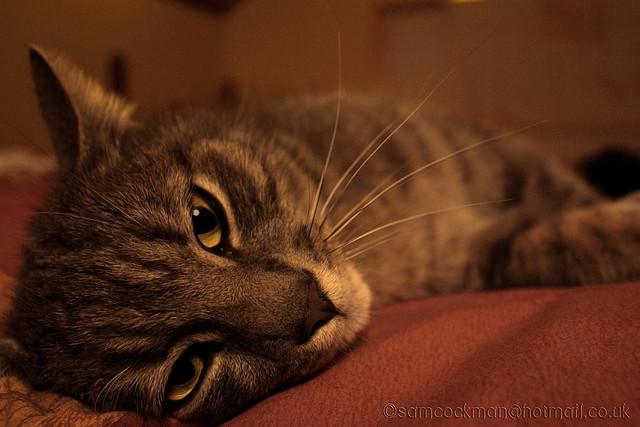Is the cat facing light?
Be succinct. Yes. Are both eyes open?
Give a very brief answer. Yes. What color is the cat's eyes?
Write a very short answer. Yellow. Does the cat look happy?
Concise answer only. Yes. What color is the cat laying down?
Give a very brief answer. Gray. Does the cat's tongue touch his nose?
Concise answer only. No. How many whiskers are shown in the picture?
Short answer required. 8. Is this animal carnivorous?
Concise answer only. Yes. How many whiskers are on the left side of the cat's nose?
Concise answer only. 8. 